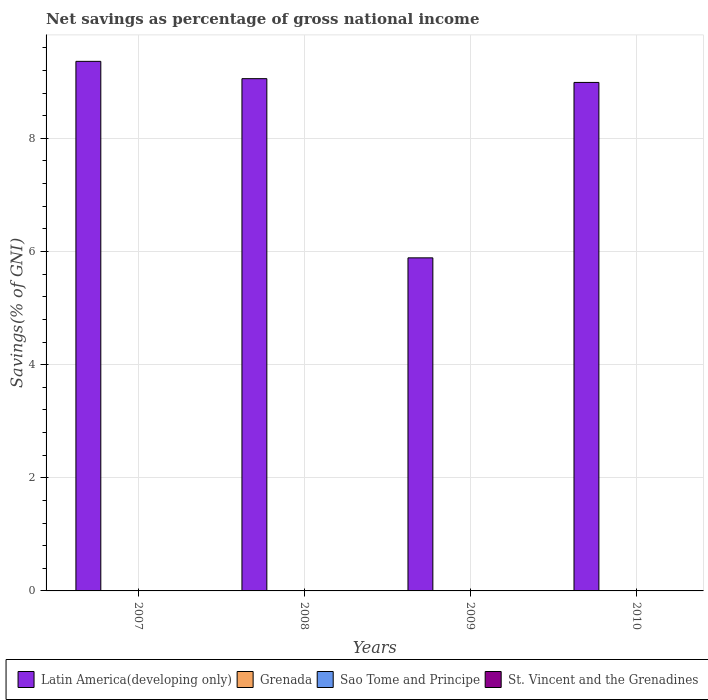How many different coloured bars are there?
Provide a succinct answer. 1. Are the number of bars per tick equal to the number of legend labels?
Ensure brevity in your answer.  No. What is the total savings in Latin America(developing only) in 2007?
Provide a short and direct response. 9.36. What is the total total savings in Latin America(developing only) in the graph?
Your response must be concise. 33.29. What is the difference between the total savings in Latin America(developing only) in 2008 and that in 2009?
Keep it short and to the point. 3.17. What is the ratio of the total savings in Latin America(developing only) in 2007 to that in 2010?
Offer a very short reply. 1.04. What is the difference between the highest and the second highest total savings in Latin America(developing only)?
Ensure brevity in your answer.  0.31. What is the difference between the highest and the lowest total savings in Latin America(developing only)?
Give a very brief answer. 3.47. What is the difference between two consecutive major ticks on the Y-axis?
Your response must be concise. 2. Does the graph contain any zero values?
Your answer should be compact. Yes. Where does the legend appear in the graph?
Ensure brevity in your answer.  Bottom right. How many legend labels are there?
Provide a succinct answer. 4. How are the legend labels stacked?
Provide a succinct answer. Horizontal. What is the title of the graph?
Provide a short and direct response. Net savings as percentage of gross national income. Does "Dominica" appear as one of the legend labels in the graph?
Keep it short and to the point. No. What is the label or title of the Y-axis?
Your answer should be compact. Savings(% of GNI). What is the Savings(% of GNI) of Latin America(developing only) in 2007?
Make the answer very short. 9.36. What is the Savings(% of GNI) in Sao Tome and Principe in 2007?
Keep it short and to the point. 0. What is the Savings(% of GNI) of Latin America(developing only) in 2008?
Ensure brevity in your answer.  9.06. What is the Savings(% of GNI) of Grenada in 2008?
Your answer should be very brief. 0. What is the Savings(% of GNI) of Sao Tome and Principe in 2008?
Keep it short and to the point. 0. What is the Savings(% of GNI) of Latin America(developing only) in 2009?
Provide a succinct answer. 5.89. What is the Savings(% of GNI) in Latin America(developing only) in 2010?
Offer a terse response. 8.99. What is the Savings(% of GNI) of Sao Tome and Principe in 2010?
Provide a succinct answer. 0. Across all years, what is the maximum Savings(% of GNI) of Latin America(developing only)?
Your answer should be compact. 9.36. Across all years, what is the minimum Savings(% of GNI) of Latin America(developing only)?
Keep it short and to the point. 5.89. What is the total Savings(% of GNI) in Latin America(developing only) in the graph?
Ensure brevity in your answer.  33.29. What is the total Savings(% of GNI) of St. Vincent and the Grenadines in the graph?
Your answer should be very brief. 0. What is the difference between the Savings(% of GNI) in Latin America(developing only) in 2007 and that in 2008?
Provide a succinct answer. 0.31. What is the difference between the Savings(% of GNI) in Latin America(developing only) in 2007 and that in 2009?
Your answer should be very brief. 3.47. What is the difference between the Savings(% of GNI) of Latin America(developing only) in 2007 and that in 2010?
Offer a very short reply. 0.37. What is the difference between the Savings(% of GNI) in Latin America(developing only) in 2008 and that in 2009?
Keep it short and to the point. 3.17. What is the difference between the Savings(% of GNI) of Latin America(developing only) in 2008 and that in 2010?
Your response must be concise. 0.07. What is the difference between the Savings(% of GNI) in Latin America(developing only) in 2009 and that in 2010?
Your response must be concise. -3.1. What is the average Savings(% of GNI) in Latin America(developing only) per year?
Ensure brevity in your answer.  8.32. What is the average Savings(% of GNI) of Grenada per year?
Provide a short and direct response. 0. What is the average Savings(% of GNI) in Sao Tome and Principe per year?
Provide a short and direct response. 0. What is the ratio of the Savings(% of GNI) in Latin America(developing only) in 2007 to that in 2008?
Make the answer very short. 1.03. What is the ratio of the Savings(% of GNI) in Latin America(developing only) in 2007 to that in 2009?
Provide a succinct answer. 1.59. What is the ratio of the Savings(% of GNI) in Latin America(developing only) in 2007 to that in 2010?
Ensure brevity in your answer.  1.04. What is the ratio of the Savings(% of GNI) of Latin America(developing only) in 2008 to that in 2009?
Offer a very short reply. 1.54. What is the ratio of the Savings(% of GNI) of Latin America(developing only) in 2008 to that in 2010?
Give a very brief answer. 1.01. What is the ratio of the Savings(% of GNI) of Latin America(developing only) in 2009 to that in 2010?
Your answer should be compact. 0.66. What is the difference between the highest and the second highest Savings(% of GNI) in Latin America(developing only)?
Make the answer very short. 0.31. What is the difference between the highest and the lowest Savings(% of GNI) of Latin America(developing only)?
Provide a short and direct response. 3.47. 